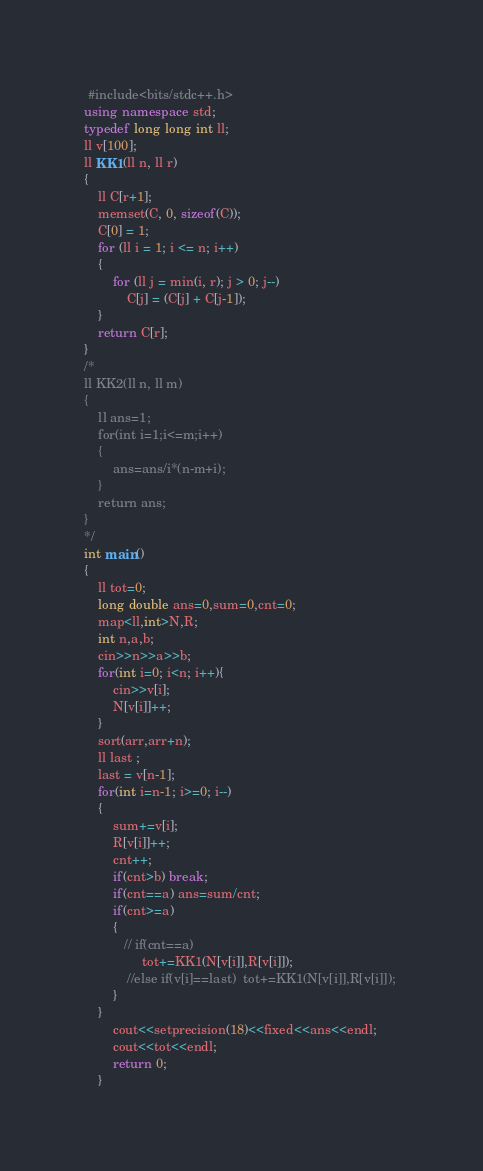<code> <loc_0><loc_0><loc_500><loc_500><_C++_> #include<bits/stdc++.h>
using namespace std;
typedef long long int ll;
ll v[100];
ll KK1(ll n, ll r)
{
    ll C[r+1];
    memset(C, 0, sizeof(C));
    C[0] = 1;
    for (ll i = 1; i <= n; i++)
    {
        for (ll j = min(i, r); j > 0; j--)
            C[j] = (C[j] + C[j-1]);
    }
    return C[r];
}
/*
ll KK2(ll n, ll m)
{
	ll ans=1;
	for(int i=1;i<=m;i++)
	{
		ans=ans/i*(n-m+i);
	}
	return ans;
}
*/
int main()
{
    ll tot=0;
    long double ans=0,sum=0,cnt=0;
    map<ll,int>N,R;
    int n,a,b;
    cin>>n>>a>>b;
    for(int i=0; i<n; i++){
       	cin>>v[i];
		N[v[i]]++;
	}
    sort(arr,arr+n);
    ll last ;
    last = v[n-1];
    for(int i=n-1; i>=0; i--)
    {
        sum+=v[i];
        R[v[i]]++;
        cnt++;
        if(cnt>b) break;
        if(cnt==a) ans=sum/cnt; 
        if(cnt>=a)
        {
           // if(cnt==a)  
				tot+=KK1(N[v[i]],R[v[i]]);
            //else if(v[i]==last)  tot+=KK1(N[v[i]],R[v[i]]); 
        }
    }
        cout<<setprecision(18)<<fixed<<ans<<endl;
        cout<<tot<<endl;
        return 0;
    }
</code> 